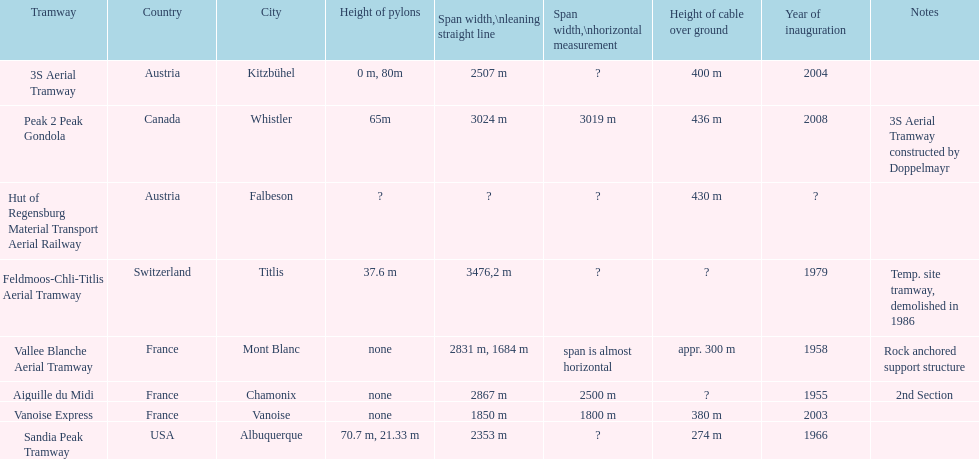What is the difference in length between the peak 2 peak gondola and the 32 aerial tramway? 517. 